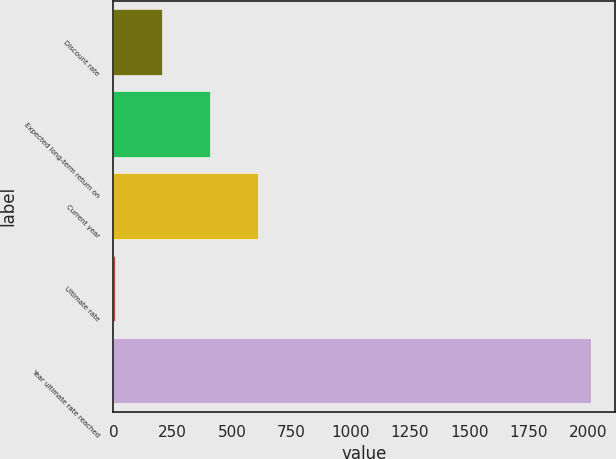Convert chart to OTSL. <chart><loc_0><loc_0><loc_500><loc_500><bar_chart><fcel>Discount rate<fcel>Expected long-term return on<fcel>Current year<fcel>Ultimate rate<fcel>Year ultimate rate reached<nl><fcel>206<fcel>407<fcel>608<fcel>5<fcel>2015<nl></chart> 